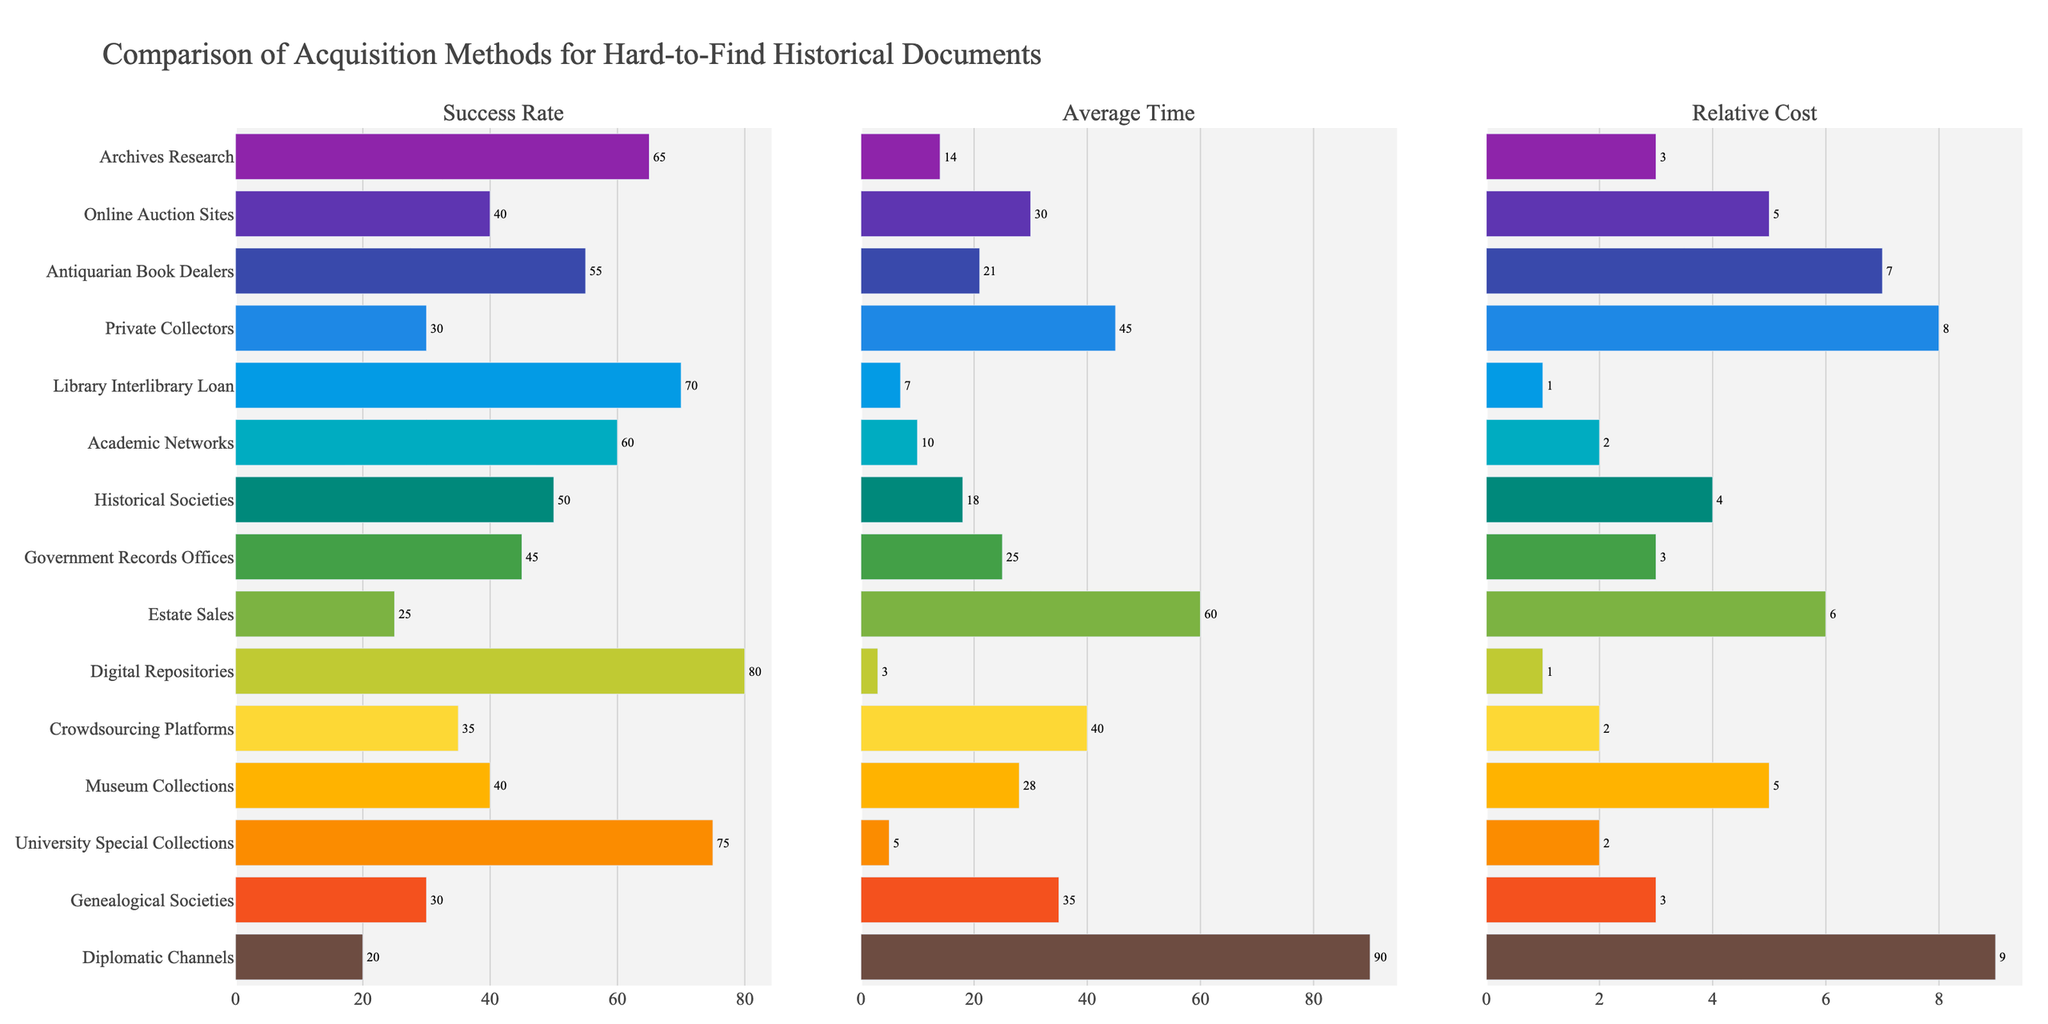Which method has the highest success rate? The success rate is visually depicted as a horizontal bar, and the longest bar corresponds to the highest success rate. The method with the longest bar in the "Success Rate" subplot is "Digital Repositories" with 80%.
Answer: Digital Repositories Which method has the lowest average acquisition time? The average time is shown as horizontal bars, and the shortest bar indicates the lowest time. The method with the shortest bar in the "Average Time" subplot is "Digital Repositories" at 3 days.
Answer: Digital Repositories What is the relative cost difference between "University Special Collections" and "Diplomatic Channels"? The relative cost is shown as horizontal bars. "Diplomatic Channels" have a relative cost of 9, while "University Special Collections" have a relative cost of 2. The difference is 9 - 2.
Answer: 7 Which methods have a success rate equal to or greater than 70%? By observing the "Success Rate" subplot, identify bars that reach or exceed the 70% mark. The methods are "Library Interlibrary Loan" (70%), "University Special Collections" (75%), and "Digital Repositories" (80%).
Answer: Library Interlibrary Loan, University Special Collections, Digital Repositories Which acquisition method has the highest relative cost and what is its success rate? The highest relative cost is identified by the longest bar in the "Relative Cost" subplot, which is "Diplomatic Channels" at 9. The corresponding success rate in the "Success Rate" subplot for this method is 20%.
Answer: Diplomatic Channels; 20% Compare the success rates of "Archives Research" and "Antiquarian Book Dealers." Which one is higher? In the "Success Rate" subplot, the "Archives Research" method has a bar extending to 65%, while "Antiquarian Book Dealers" extends to 55%. "Archives Research" has a higher success rate.
Answer: Archives Research What is the difference in the average acquisition time between "Online Auction Sites" and "Genealogical Societies"? The average time for "Online Auction Sites" is 30 days and for "Genealogical Societies" is 35 days. The difference is 35 - 30.
Answer: 5 days In terms of relative cost, which method is more expensive: "Private Collectors" or "Estate Sales"? The relative cost bars for "Private Collectors" and "Estate Sales" show that "Private Collectors" has a cost of 8, whereas "Estate Sales" has a cost of 6. "Private Collectors" is more expensive.
Answer: Private Collectors What is the median success rate of all the methods? Order the success rates: 20, 25, 30, 30, 35, 40, 40, 45, 50, 55, 60, 65, 70, 75, 80. The median value is the middle one in this ordered list.
Answer: 50 